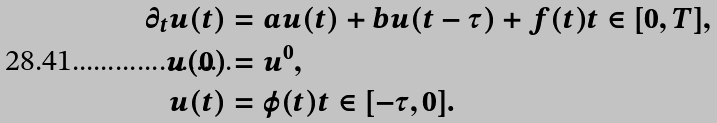<formula> <loc_0><loc_0><loc_500><loc_500>\partial _ { t } u ( t ) & = a u ( t ) + b u ( t - \tau ) + f ( t ) t \in [ 0 , T ] , \\ u ( 0 ) & = u ^ { 0 } , \\ u ( t ) & = \varphi ( t ) t \in [ - \tau , 0 ] .</formula> 